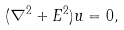<formula> <loc_0><loc_0><loc_500><loc_500>( \nabla ^ { 2 } + E ^ { 2 } ) u = 0 ,</formula> 